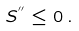Convert formula to latex. <formula><loc_0><loc_0><loc_500><loc_500>S ^ { ^ { \prime \prime } } \leq 0 \, .</formula> 